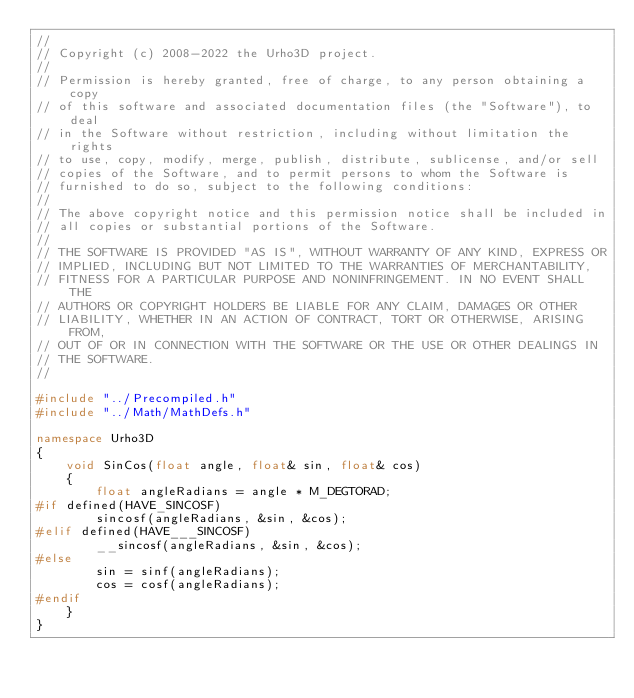Convert code to text. <code><loc_0><loc_0><loc_500><loc_500><_C++_>//
// Copyright (c) 2008-2022 the Urho3D project.
//
// Permission is hereby granted, free of charge, to any person obtaining a copy
// of this software and associated documentation files (the "Software"), to deal
// in the Software without restriction, including without limitation the rights
// to use, copy, modify, merge, publish, distribute, sublicense, and/or sell
// copies of the Software, and to permit persons to whom the Software is
// furnished to do so, subject to the following conditions:
//
// The above copyright notice and this permission notice shall be included in
// all copies or substantial portions of the Software.
//
// THE SOFTWARE IS PROVIDED "AS IS", WITHOUT WARRANTY OF ANY KIND, EXPRESS OR
// IMPLIED, INCLUDING BUT NOT LIMITED TO THE WARRANTIES OF MERCHANTABILITY,
// FITNESS FOR A PARTICULAR PURPOSE AND NONINFRINGEMENT. IN NO EVENT SHALL THE
// AUTHORS OR COPYRIGHT HOLDERS BE LIABLE FOR ANY CLAIM, DAMAGES OR OTHER
// LIABILITY, WHETHER IN AN ACTION OF CONTRACT, TORT OR OTHERWISE, ARISING FROM,
// OUT OF OR IN CONNECTION WITH THE SOFTWARE OR THE USE OR OTHER DEALINGS IN
// THE SOFTWARE.
//

#include "../Precompiled.h"
#include "../Math/MathDefs.h"

namespace Urho3D
{
    void SinCos(float angle, float& sin, float& cos)
    {
        float angleRadians = angle * M_DEGTORAD;
#if defined(HAVE_SINCOSF)
        sincosf(angleRadians, &sin, &cos);
#elif defined(HAVE___SINCOSF)
        __sincosf(angleRadians, &sin, &cos);
#else
        sin = sinf(angleRadians);
        cos = cosf(angleRadians);
#endif
    }
}
</code> 